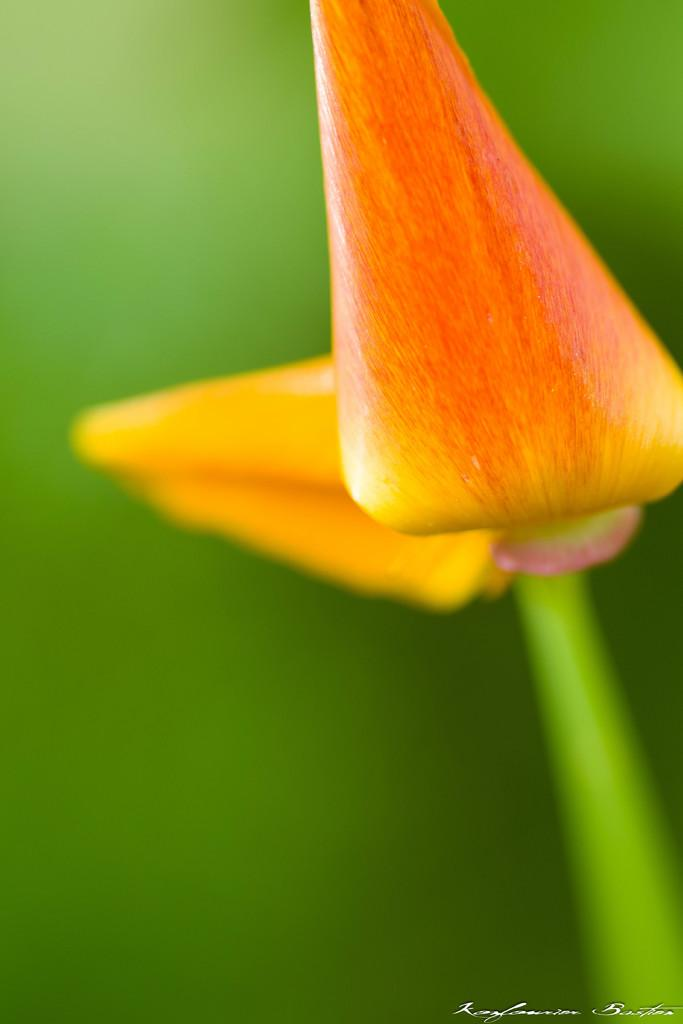What is present in the image? There are buds in the image. What color is the background of the image? The background of the image is green. How many quince are visible in the image? There are no quince present in the image; it only features buds. What type of flock can be seen flying in the image? There is no flock visible in the image; it only features buds and a green background. 